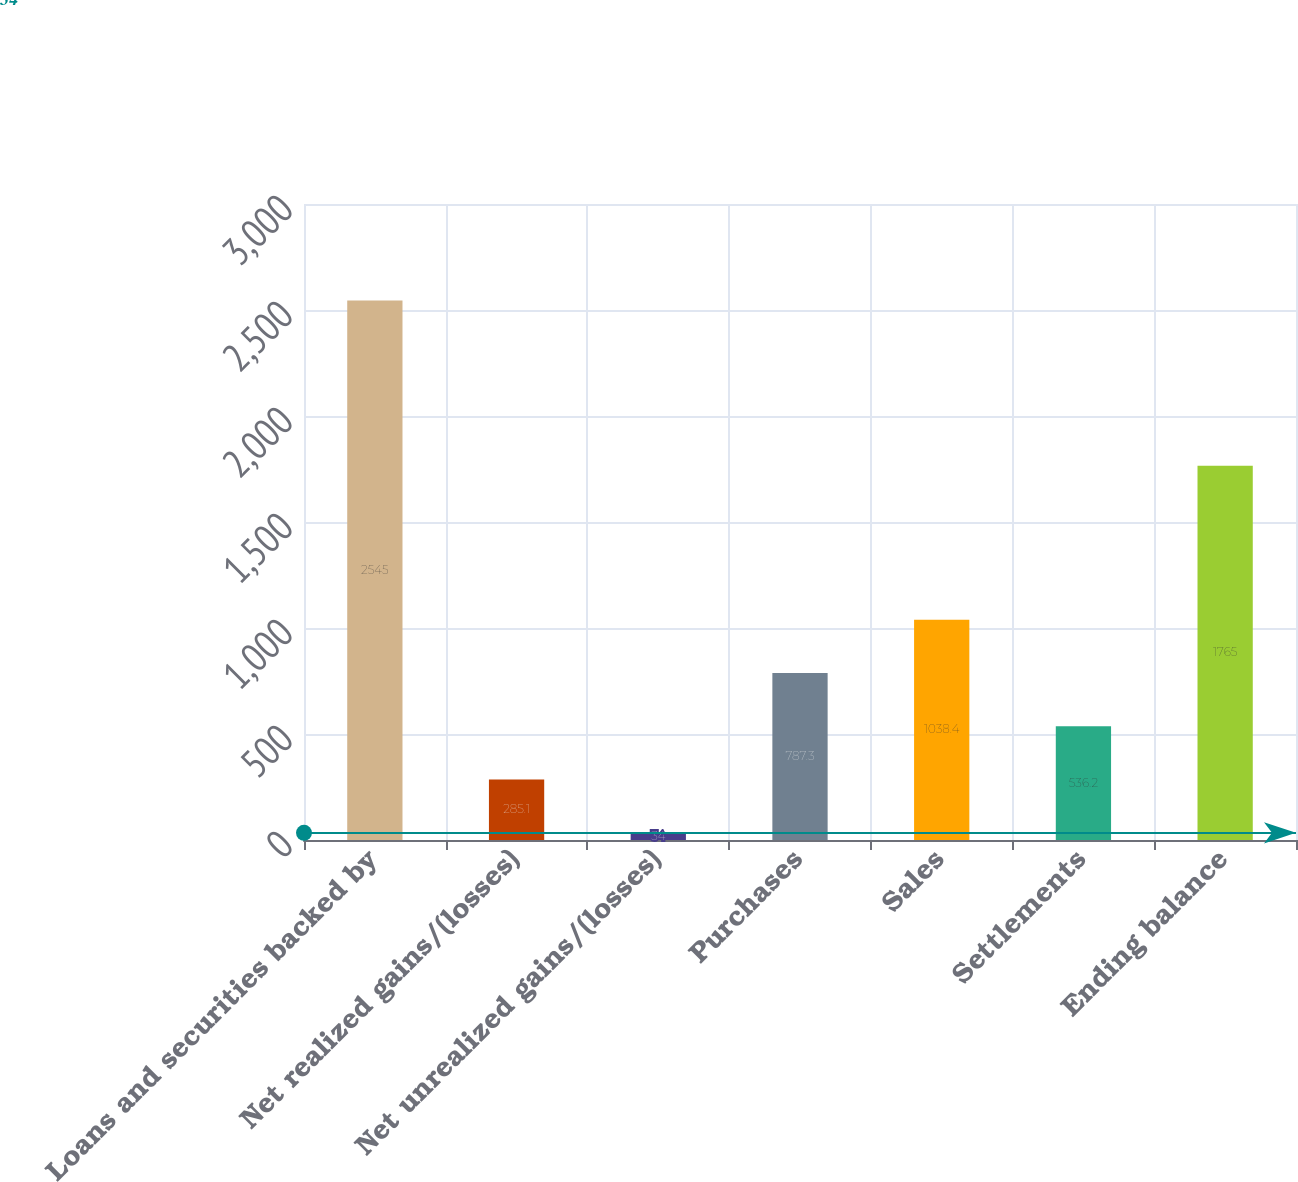<chart> <loc_0><loc_0><loc_500><loc_500><bar_chart><fcel>Loans and securities backed by<fcel>Net realized gains/(losses)<fcel>Net unrealized gains/(losses)<fcel>Purchases<fcel>Sales<fcel>Settlements<fcel>Ending balance<nl><fcel>2545<fcel>285.1<fcel>34<fcel>787.3<fcel>1038.4<fcel>536.2<fcel>1765<nl></chart> 